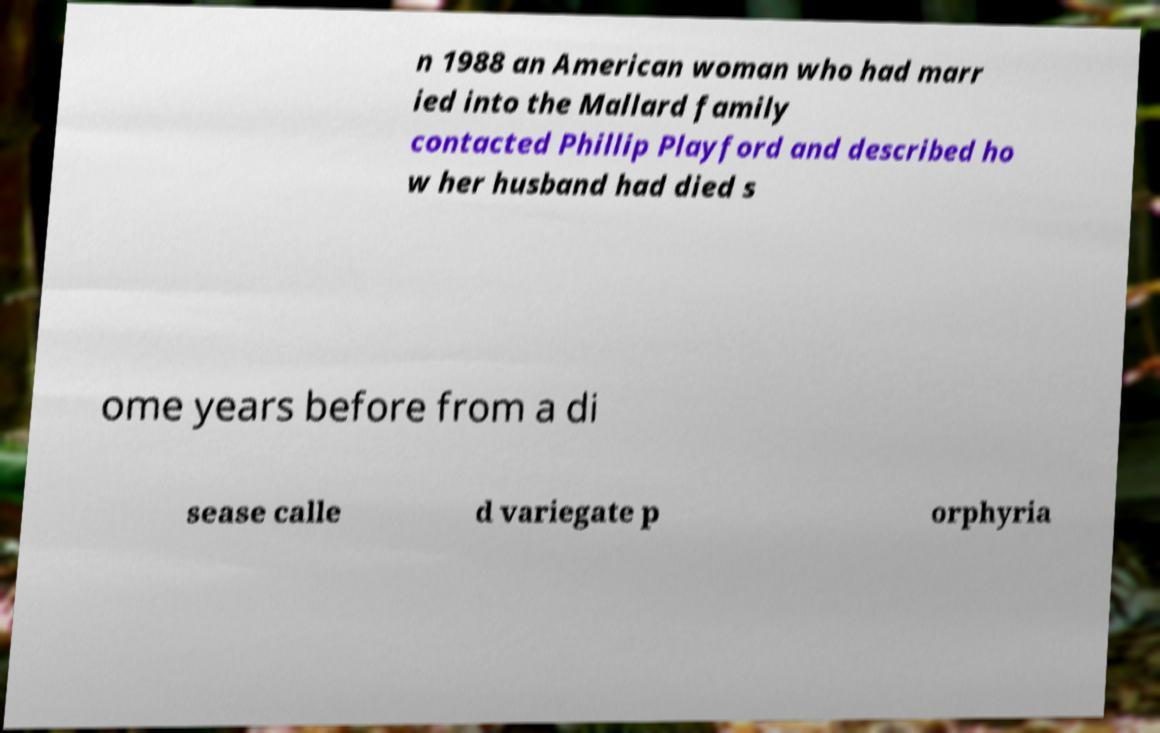Please read and relay the text visible in this image. What does it say? n 1988 an American woman who had marr ied into the Mallard family contacted Phillip Playford and described ho w her husband had died s ome years before from a di sease calle d variegate p orphyria 